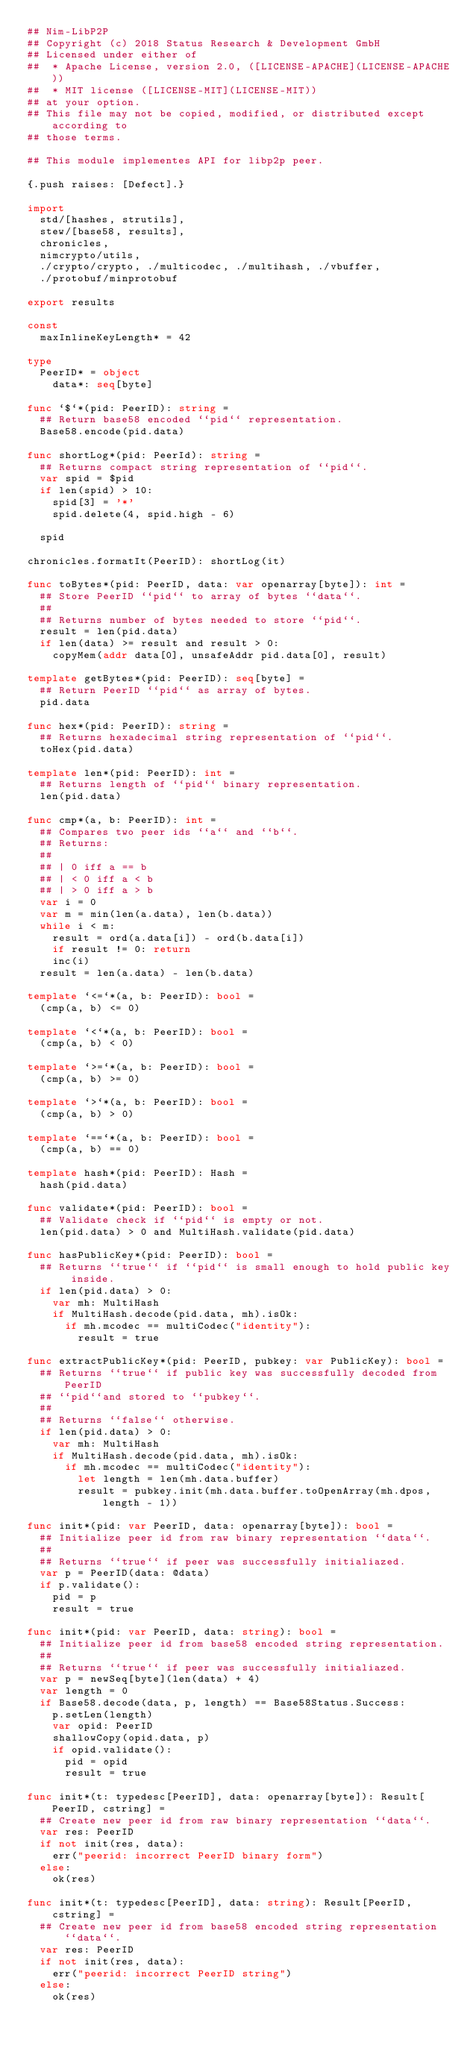<code> <loc_0><loc_0><loc_500><loc_500><_Nim_>## Nim-LibP2P
## Copyright (c) 2018 Status Research & Development GmbH
## Licensed under either of
##  * Apache License, version 2.0, ([LICENSE-APACHE](LICENSE-APACHE))
##  * MIT license ([LICENSE-MIT](LICENSE-MIT))
## at your option.
## This file may not be copied, modified, or distributed except according to
## those terms.

## This module implementes API for libp2p peer.

{.push raises: [Defect].}

import
  std/[hashes, strutils],
  stew/[base58, results],
  chronicles,
  nimcrypto/utils,
  ./crypto/crypto, ./multicodec, ./multihash, ./vbuffer,
  ./protobuf/minprotobuf

export results

const
  maxInlineKeyLength* = 42

type
  PeerID* = object
    data*: seq[byte]

func `$`*(pid: PeerID): string =
  ## Return base58 encoded ``pid`` representation.
  Base58.encode(pid.data)

func shortLog*(pid: PeerId): string =
  ## Returns compact string representation of ``pid``.
  var spid = $pid
  if len(spid) > 10:
    spid[3] = '*'
    spid.delete(4, spid.high - 6)

  spid

chronicles.formatIt(PeerID): shortLog(it)

func toBytes*(pid: PeerID, data: var openarray[byte]): int =
  ## Store PeerID ``pid`` to array of bytes ``data``.
  ##
  ## Returns number of bytes needed to store ``pid``.
  result = len(pid.data)
  if len(data) >= result and result > 0:
    copyMem(addr data[0], unsafeAddr pid.data[0], result)

template getBytes*(pid: PeerID): seq[byte] =
  ## Return PeerID ``pid`` as array of bytes.
  pid.data

func hex*(pid: PeerID): string =
  ## Returns hexadecimal string representation of ``pid``.
  toHex(pid.data)

template len*(pid: PeerID): int =
  ## Returns length of ``pid`` binary representation.
  len(pid.data)

func cmp*(a, b: PeerID): int =
  ## Compares two peer ids ``a`` and ``b``.
  ## Returns:
  ##
  ## | 0 iff a == b
  ## | < 0 iff a < b
  ## | > 0 iff a > b
  var i = 0
  var m = min(len(a.data), len(b.data))
  while i < m:
    result = ord(a.data[i]) - ord(b.data[i])
    if result != 0: return
    inc(i)
  result = len(a.data) - len(b.data)

template `<=`*(a, b: PeerID): bool =
  (cmp(a, b) <= 0)

template `<`*(a, b: PeerID): bool =
  (cmp(a, b) < 0)

template `>=`*(a, b: PeerID): bool =
  (cmp(a, b) >= 0)

template `>`*(a, b: PeerID): bool =
  (cmp(a, b) > 0)

template `==`*(a, b: PeerID): bool =
  (cmp(a, b) == 0)

template hash*(pid: PeerID): Hash =
  hash(pid.data)

func validate*(pid: PeerID): bool =
  ## Validate check if ``pid`` is empty or not.
  len(pid.data) > 0 and MultiHash.validate(pid.data)

func hasPublicKey*(pid: PeerID): bool =
  ## Returns ``true`` if ``pid`` is small enough to hold public key inside.
  if len(pid.data) > 0:
    var mh: MultiHash
    if MultiHash.decode(pid.data, mh).isOk:
      if mh.mcodec == multiCodec("identity"):
        result = true

func extractPublicKey*(pid: PeerID, pubkey: var PublicKey): bool =
  ## Returns ``true`` if public key was successfully decoded from PeerID
  ## ``pid``and stored to ``pubkey``.
  ##
  ## Returns ``false`` otherwise.
  if len(pid.data) > 0:
    var mh: MultiHash
    if MultiHash.decode(pid.data, mh).isOk:
      if mh.mcodec == multiCodec("identity"):
        let length = len(mh.data.buffer)
        result = pubkey.init(mh.data.buffer.toOpenArray(mh.dpos, length - 1))

func init*(pid: var PeerID, data: openarray[byte]): bool =
  ## Initialize peer id from raw binary representation ``data``.
  ##
  ## Returns ``true`` if peer was successfully initialiazed.
  var p = PeerID(data: @data)
  if p.validate():
    pid = p
    result = true

func init*(pid: var PeerID, data: string): bool =
  ## Initialize peer id from base58 encoded string representation.
  ##
  ## Returns ``true`` if peer was successfully initialiazed.
  var p = newSeq[byte](len(data) + 4)
  var length = 0
  if Base58.decode(data, p, length) == Base58Status.Success:
    p.setLen(length)
    var opid: PeerID
    shallowCopy(opid.data, p)
    if opid.validate():
      pid = opid
      result = true

func init*(t: typedesc[PeerID], data: openarray[byte]): Result[PeerID, cstring] =
  ## Create new peer id from raw binary representation ``data``.
  var res: PeerID
  if not init(res, data):
    err("peerid: incorrect PeerID binary form")
  else:
    ok(res)

func init*(t: typedesc[PeerID], data: string): Result[PeerID, cstring] =
  ## Create new peer id from base58 encoded string representation ``data``.
  var res: PeerID
  if not init(res, data):
    err("peerid: incorrect PeerID string")
  else:
    ok(res)
</code> 